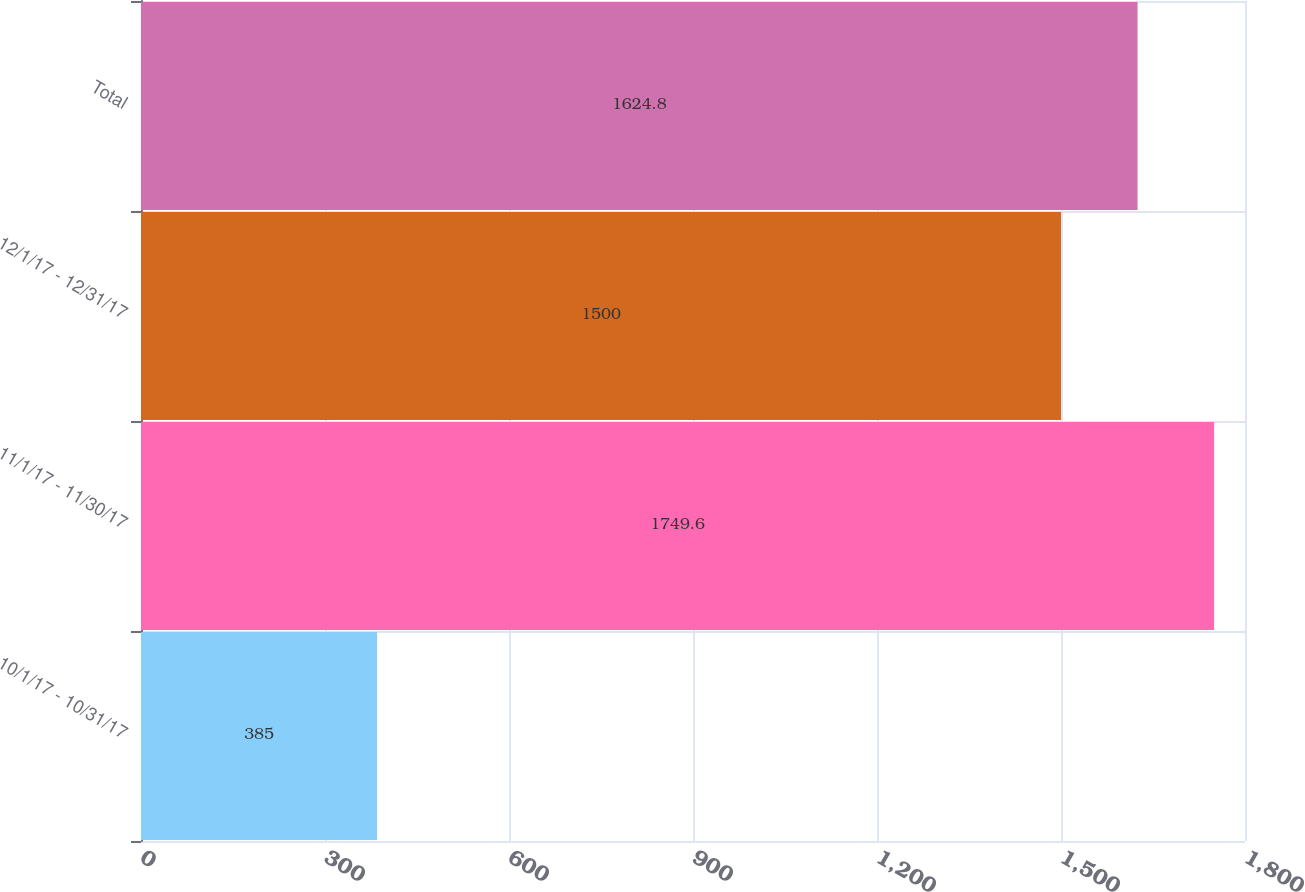Convert chart to OTSL. <chart><loc_0><loc_0><loc_500><loc_500><bar_chart><fcel>10/1/17 - 10/31/17<fcel>11/1/17 - 11/30/17<fcel>12/1/17 - 12/31/17<fcel>Total<nl><fcel>385<fcel>1749.6<fcel>1500<fcel>1624.8<nl></chart> 